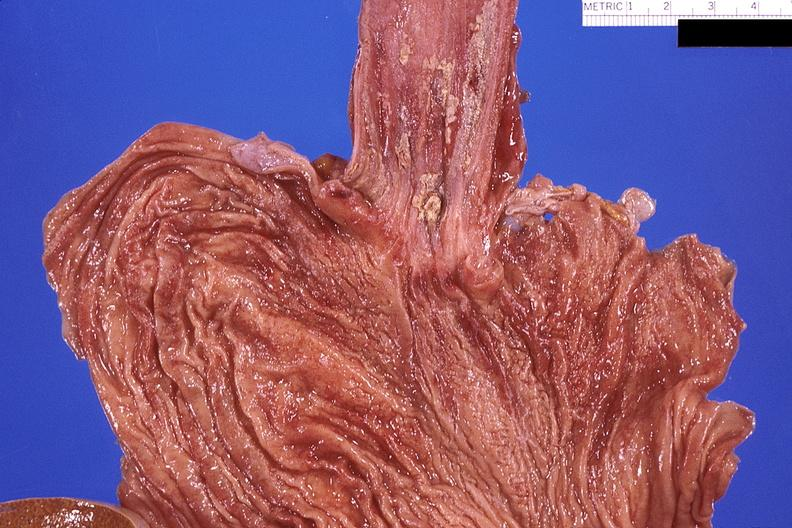s gastrointestinal present?
Answer the question using a single word or phrase. Yes 